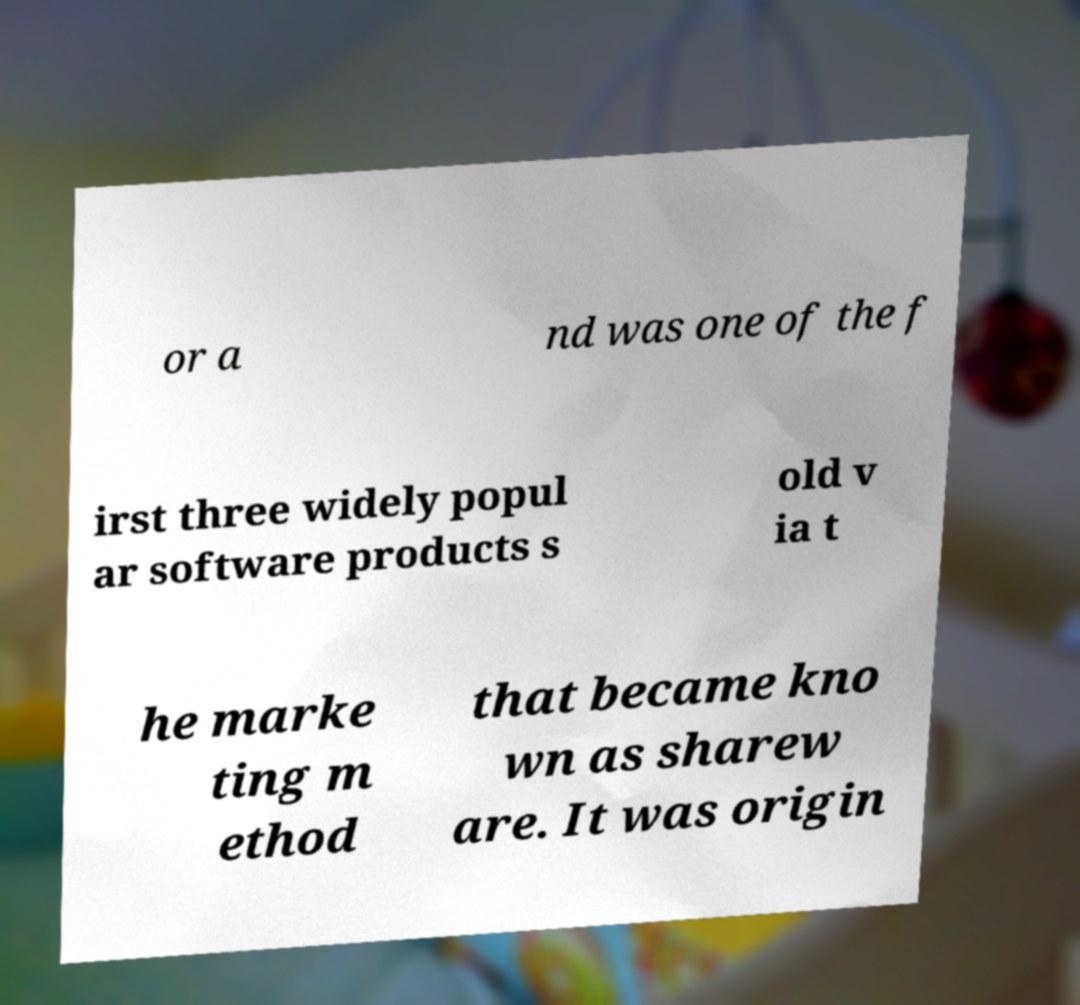For documentation purposes, I need the text within this image transcribed. Could you provide that? or a nd was one of the f irst three widely popul ar software products s old v ia t he marke ting m ethod that became kno wn as sharew are. It was origin 